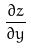Convert formula to latex. <formula><loc_0><loc_0><loc_500><loc_500>\frac { \partial z } { \partial y }</formula> 